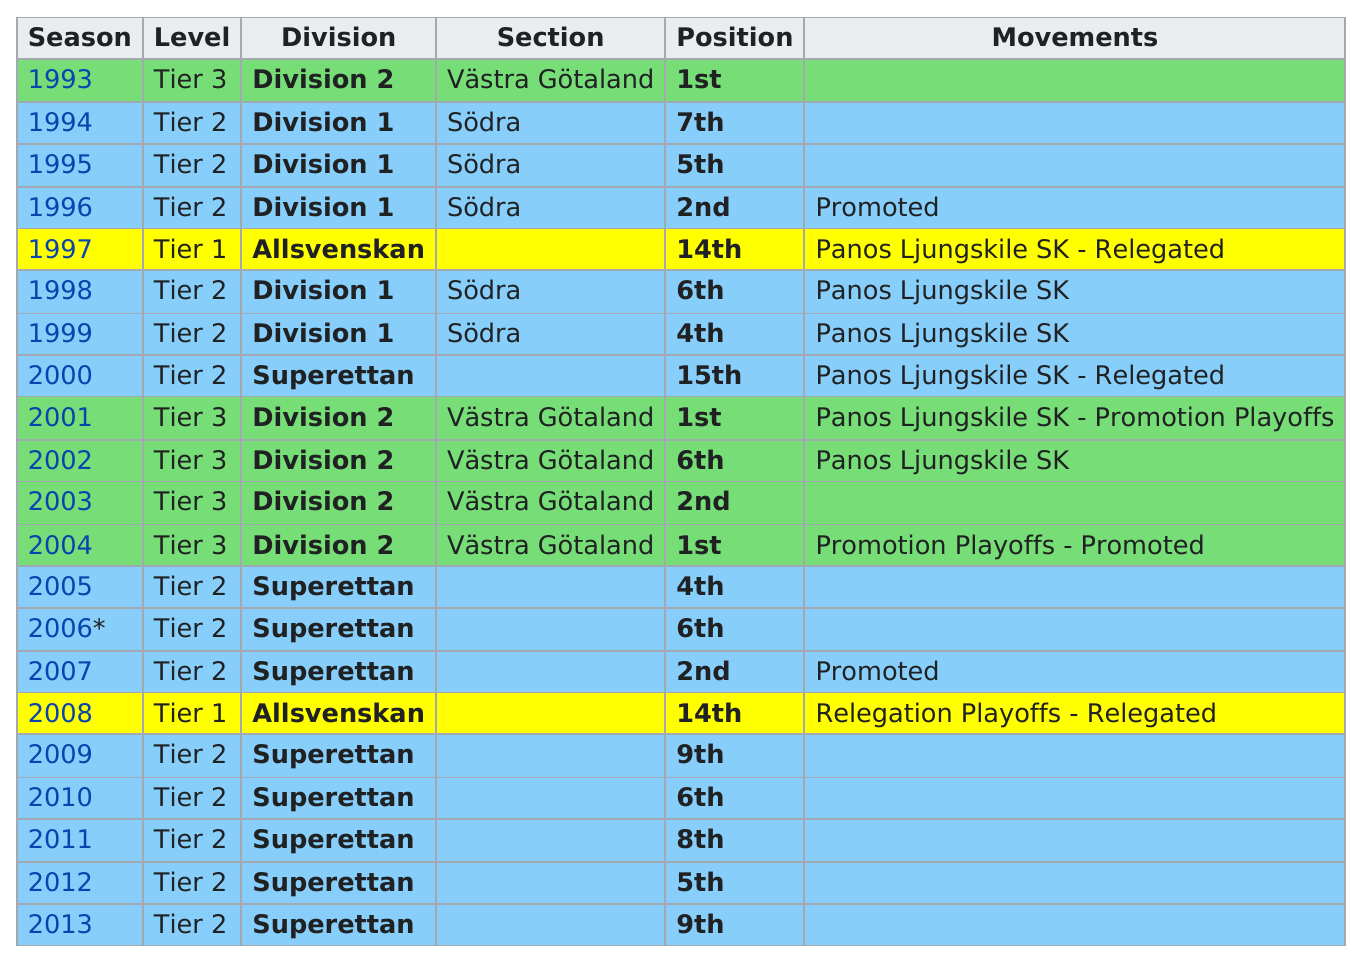Outline some significant characteristics in this image. Besides 1997, the team was also relegated in the year 2008. The team was most commonly found in Superettan division. The team has participated in a total of four different divisions. The team experienced a total of ten movements, both up and down. 